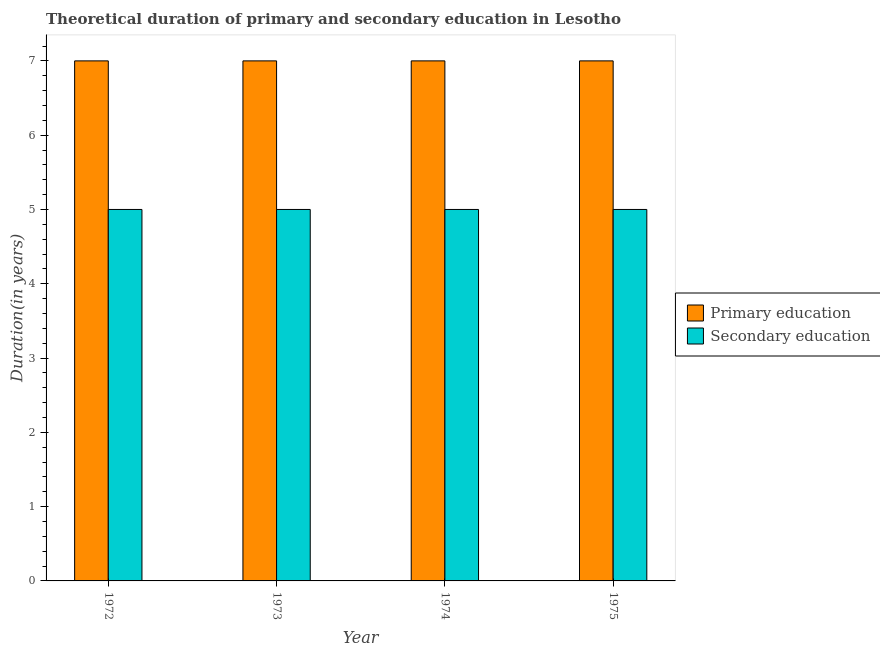How many different coloured bars are there?
Your answer should be compact. 2. How many groups of bars are there?
Your answer should be very brief. 4. Are the number of bars per tick equal to the number of legend labels?
Ensure brevity in your answer.  Yes. How many bars are there on the 3rd tick from the right?
Offer a terse response. 2. What is the label of the 4th group of bars from the left?
Your response must be concise. 1975. In how many cases, is the number of bars for a given year not equal to the number of legend labels?
Keep it short and to the point. 0. What is the duration of secondary education in 1973?
Your answer should be compact. 5. Across all years, what is the maximum duration of primary education?
Offer a terse response. 7. Across all years, what is the minimum duration of secondary education?
Provide a short and direct response. 5. In which year was the duration of secondary education maximum?
Provide a succinct answer. 1972. In which year was the duration of secondary education minimum?
Your answer should be compact. 1972. What is the total duration of secondary education in the graph?
Offer a terse response. 20. What is the difference between the duration of primary education in 1973 and that in 1975?
Your answer should be compact. 0. In how many years, is the duration of secondary education greater than 7 years?
Ensure brevity in your answer.  0. What is the ratio of the duration of secondary education in 1972 to that in 1975?
Your answer should be compact. 1. Is the difference between the duration of secondary education in 1974 and 1975 greater than the difference between the duration of primary education in 1974 and 1975?
Your answer should be very brief. No. What does the 1st bar from the left in 1972 represents?
Offer a very short reply. Primary education. What does the 1st bar from the right in 1974 represents?
Provide a succinct answer. Secondary education. How many bars are there?
Offer a very short reply. 8. Are all the bars in the graph horizontal?
Your answer should be very brief. No. How many legend labels are there?
Give a very brief answer. 2. What is the title of the graph?
Make the answer very short. Theoretical duration of primary and secondary education in Lesotho. What is the label or title of the X-axis?
Offer a very short reply. Year. What is the label or title of the Y-axis?
Your response must be concise. Duration(in years). What is the Duration(in years) in Primary education in 1972?
Offer a terse response. 7. What is the Duration(in years) of Primary education in 1973?
Keep it short and to the point. 7. What is the Duration(in years) in Primary education in 1974?
Give a very brief answer. 7. What is the Duration(in years) in Secondary education in 1975?
Your response must be concise. 5. Across all years, what is the maximum Duration(in years) in Primary education?
Provide a succinct answer. 7. What is the total Duration(in years) of Secondary education in the graph?
Your answer should be very brief. 20. What is the difference between the Duration(in years) in Primary education in 1972 and that in 1973?
Keep it short and to the point. 0. What is the difference between the Duration(in years) of Secondary education in 1972 and that in 1973?
Your response must be concise. 0. What is the difference between the Duration(in years) of Primary education in 1972 and that in 1974?
Keep it short and to the point. 0. What is the difference between the Duration(in years) of Primary education in 1972 and that in 1975?
Your response must be concise. 0. What is the difference between the Duration(in years) in Primary education in 1973 and that in 1975?
Provide a succinct answer. 0. What is the difference between the Duration(in years) of Secondary education in 1974 and that in 1975?
Give a very brief answer. 0. What is the difference between the Duration(in years) in Primary education in 1972 and the Duration(in years) in Secondary education in 1973?
Your answer should be very brief. 2. What is the average Duration(in years) of Primary education per year?
Make the answer very short. 7. In the year 1974, what is the difference between the Duration(in years) of Primary education and Duration(in years) of Secondary education?
Your answer should be very brief. 2. What is the ratio of the Duration(in years) in Secondary education in 1972 to that in 1974?
Your response must be concise. 1. What is the ratio of the Duration(in years) of Primary education in 1972 to that in 1975?
Your answer should be very brief. 1. What is the ratio of the Duration(in years) in Primary education in 1973 to that in 1974?
Your response must be concise. 1. What is the ratio of the Duration(in years) of Primary education in 1973 to that in 1975?
Offer a terse response. 1. What is the ratio of the Duration(in years) of Primary education in 1974 to that in 1975?
Your response must be concise. 1. What is the ratio of the Duration(in years) in Secondary education in 1974 to that in 1975?
Make the answer very short. 1. What is the difference between the highest and the second highest Duration(in years) of Secondary education?
Your response must be concise. 0. What is the difference between the highest and the lowest Duration(in years) of Primary education?
Offer a very short reply. 0. 